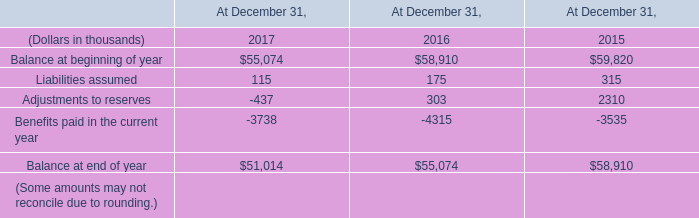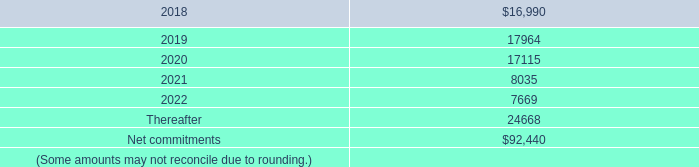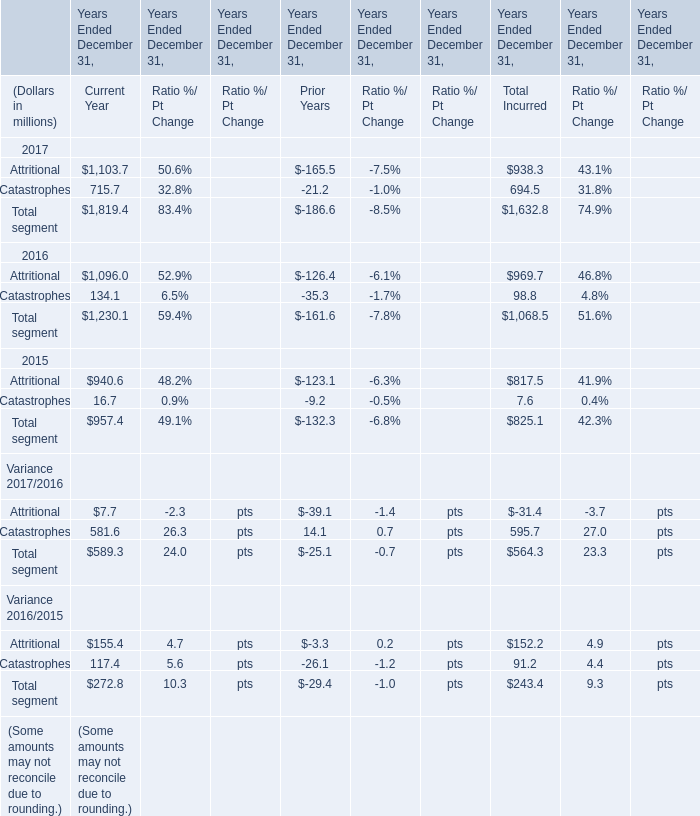what is the total value of notes issued by kilimanjaro from 2014 to 2017 , in thousands? 
Computations: ((((450000 + 500000) + 625000) + (450000 + 500000)) + 300000)
Answer: 2825000.0. 